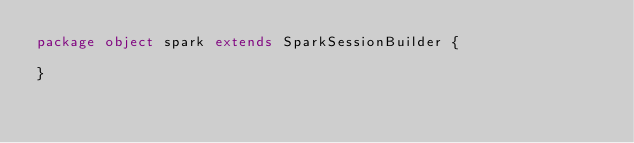<code> <loc_0><loc_0><loc_500><loc_500><_Scala_>package object spark extends SparkSessionBuilder {

}
</code> 